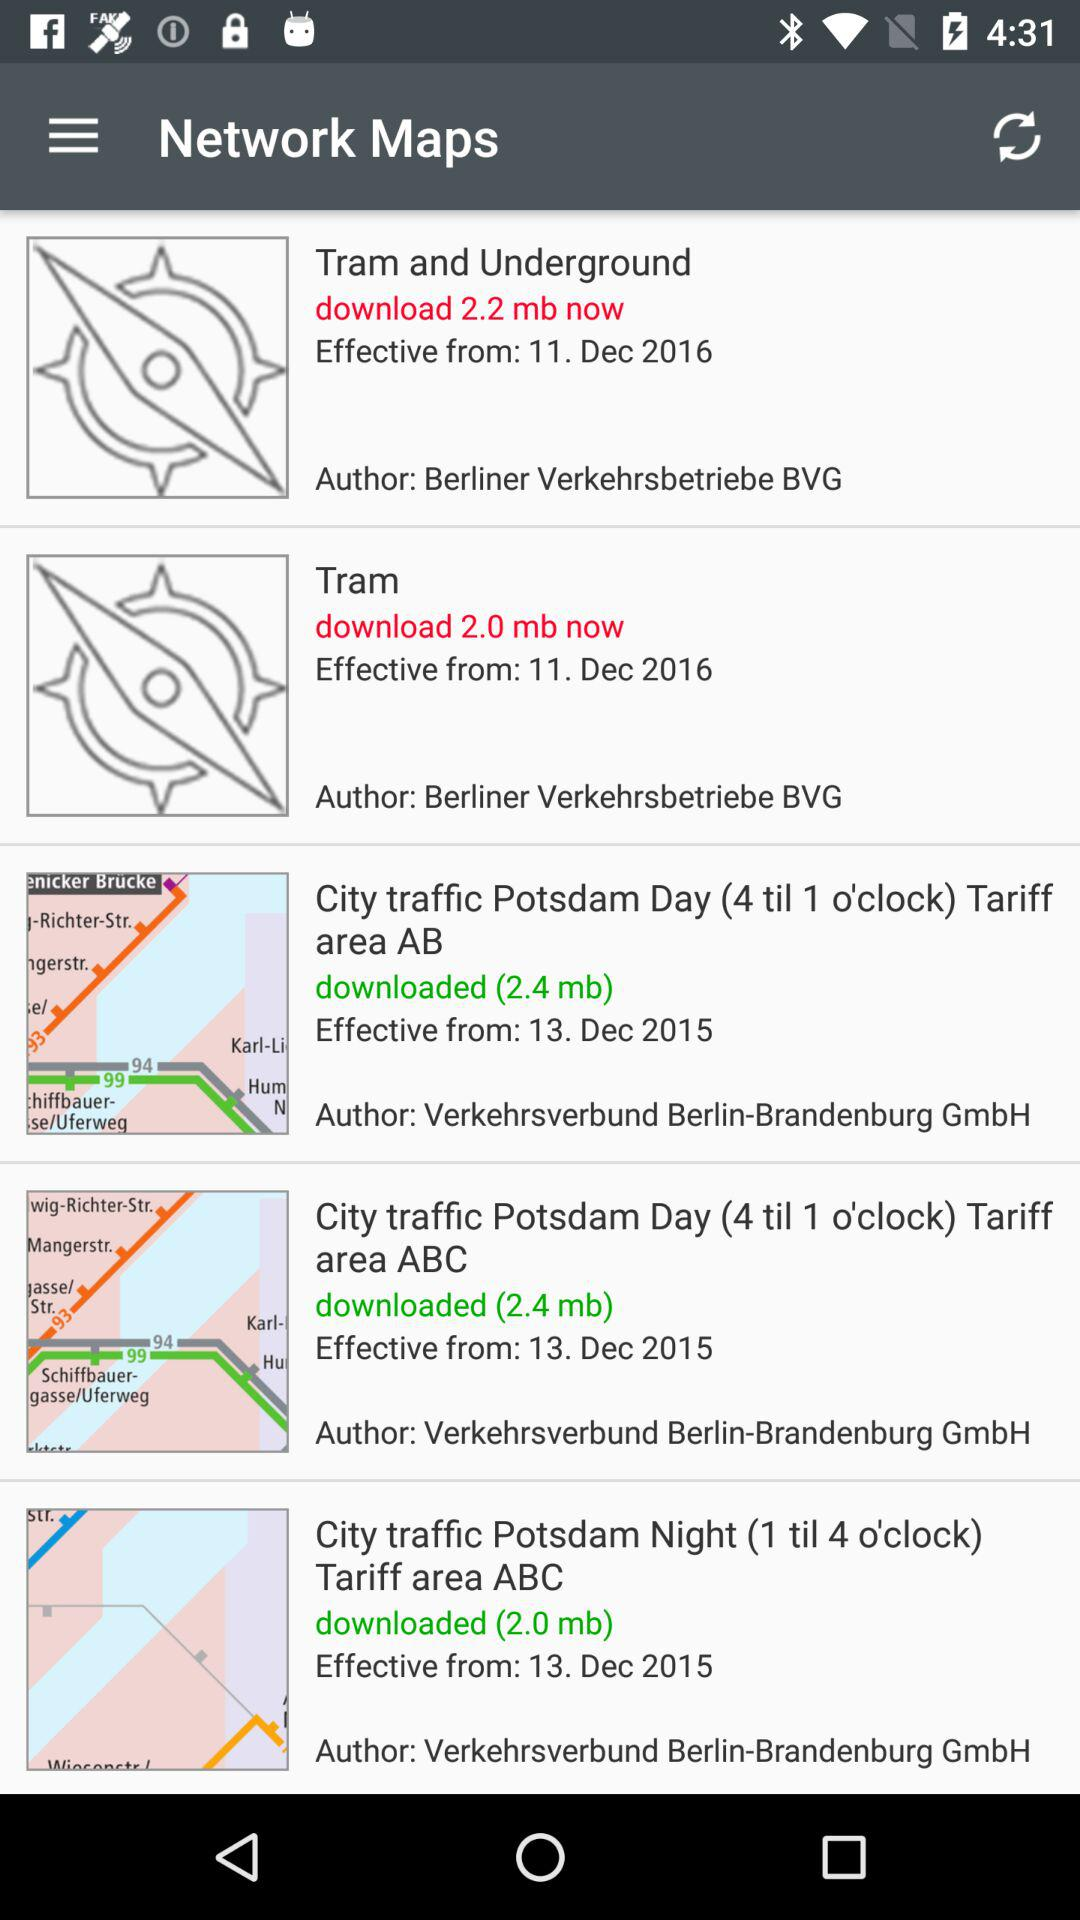What is the size of the file for the "City traffic Potsdam day (4 till 1 o'clock) Tariff area AB" map? The size of the file is 2.4 MB. 